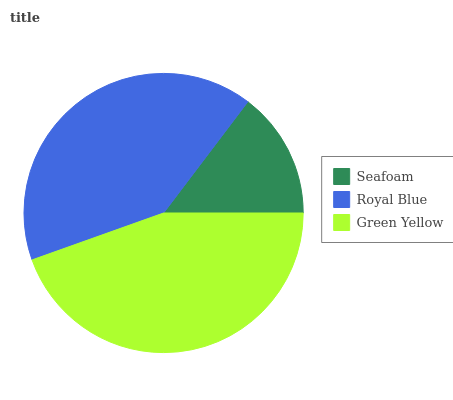Is Seafoam the minimum?
Answer yes or no. Yes. Is Green Yellow the maximum?
Answer yes or no. Yes. Is Royal Blue the minimum?
Answer yes or no. No. Is Royal Blue the maximum?
Answer yes or no. No. Is Royal Blue greater than Seafoam?
Answer yes or no. Yes. Is Seafoam less than Royal Blue?
Answer yes or no. Yes. Is Seafoam greater than Royal Blue?
Answer yes or no. No. Is Royal Blue less than Seafoam?
Answer yes or no. No. Is Royal Blue the high median?
Answer yes or no. Yes. Is Royal Blue the low median?
Answer yes or no. Yes. Is Green Yellow the high median?
Answer yes or no. No. Is Seafoam the low median?
Answer yes or no. No. 